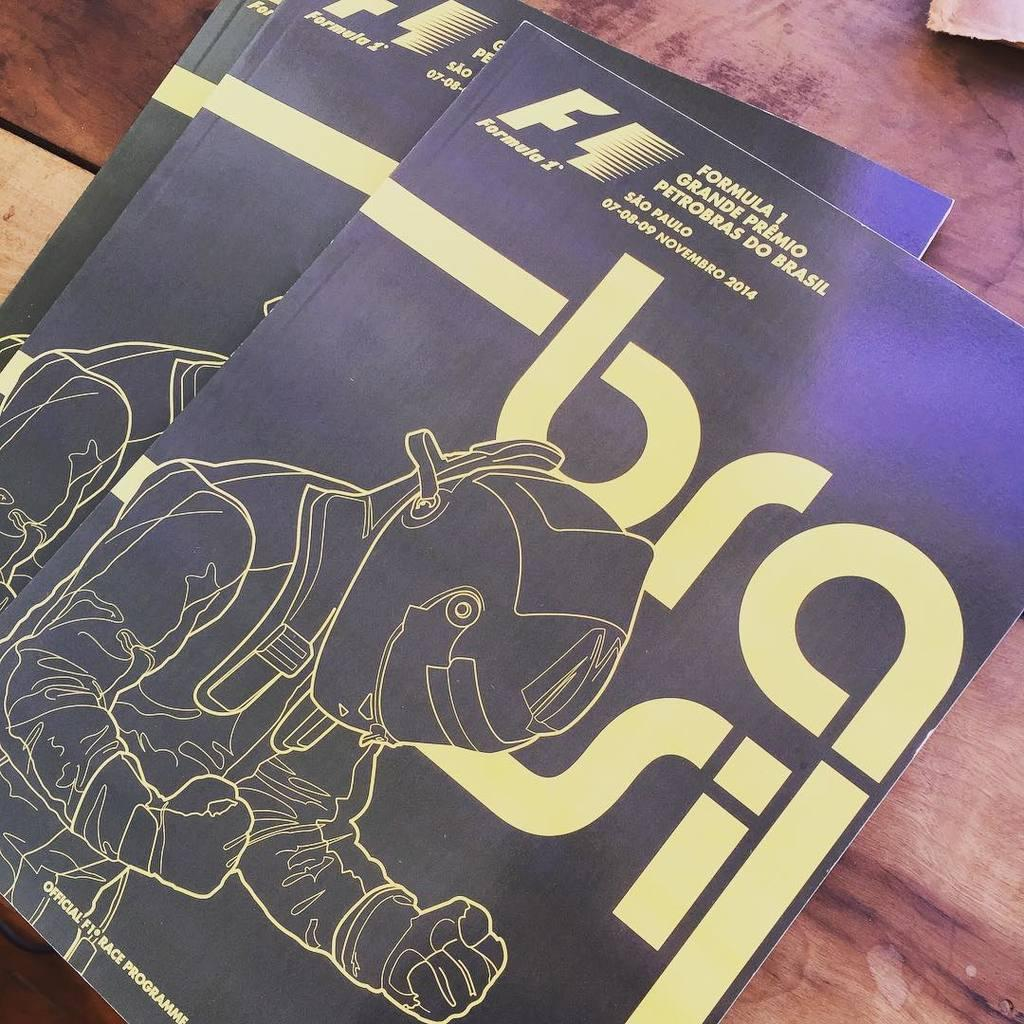<image>
Summarize the visual content of the image. Three books with a silver outline of a race car driver and the title Formula 1. 